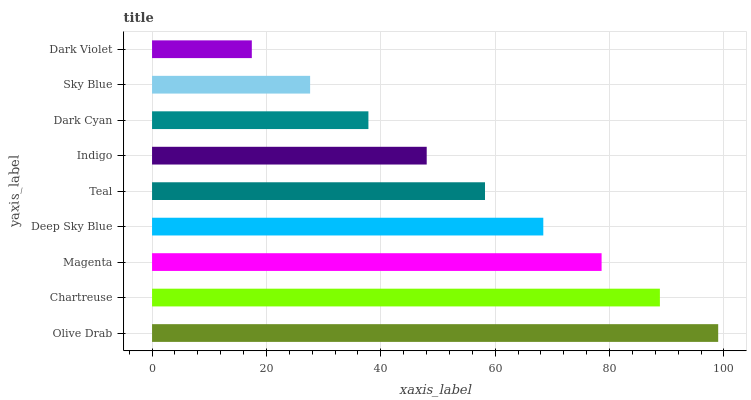Is Dark Violet the minimum?
Answer yes or no. Yes. Is Olive Drab the maximum?
Answer yes or no. Yes. Is Chartreuse the minimum?
Answer yes or no. No. Is Chartreuse the maximum?
Answer yes or no. No. Is Olive Drab greater than Chartreuse?
Answer yes or no. Yes. Is Chartreuse less than Olive Drab?
Answer yes or no. Yes. Is Chartreuse greater than Olive Drab?
Answer yes or no. No. Is Olive Drab less than Chartreuse?
Answer yes or no. No. Is Teal the high median?
Answer yes or no. Yes. Is Teal the low median?
Answer yes or no. Yes. Is Olive Drab the high median?
Answer yes or no. No. Is Chartreuse the low median?
Answer yes or no. No. 